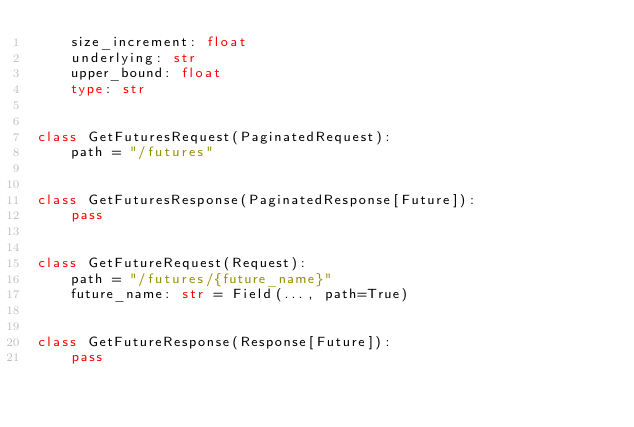<code> <loc_0><loc_0><loc_500><loc_500><_Python_>    size_increment: float
    underlying: str
    upper_bound: float
    type: str


class GetFuturesRequest(PaginatedRequest):
    path = "/futures"


class GetFuturesResponse(PaginatedResponse[Future]):
    pass


class GetFutureRequest(Request):
    path = "/futures/{future_name}"
    future_name: str = Field(..., path=True)


class GetFutureResponse(Response[Future]):
    pass
</code> 